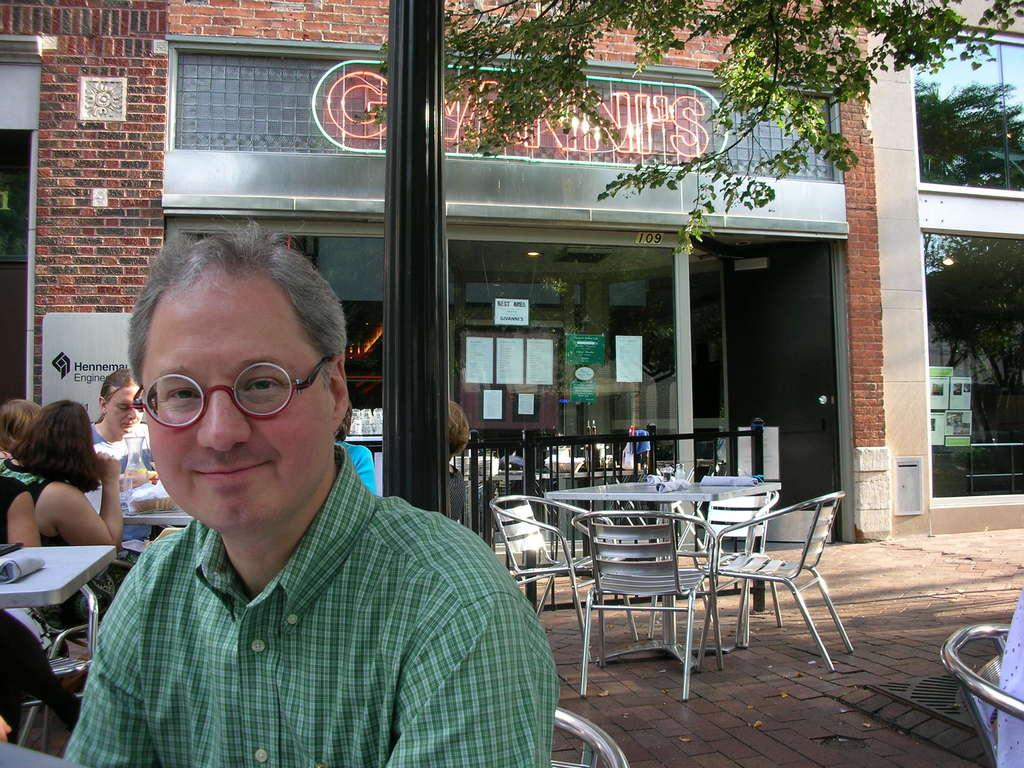What are the people in the image doing? The people in the image are sitting on chairs. Can you describe the appearance of one of the people? One person is wearing glasses. How is the person with glasses feeling? The person wearing glasses is smiling. What can be seen in the background of the image? There are additional chairs and tables in the background of the image. What channel is the person with glasses watching in the image? There is no television or channel visible in the image; it only shows people sitting on chairs. What type of material is the person with glasses rubbing on their arm? There is no indication that the person with glasses is rubbing anything on their arm. 